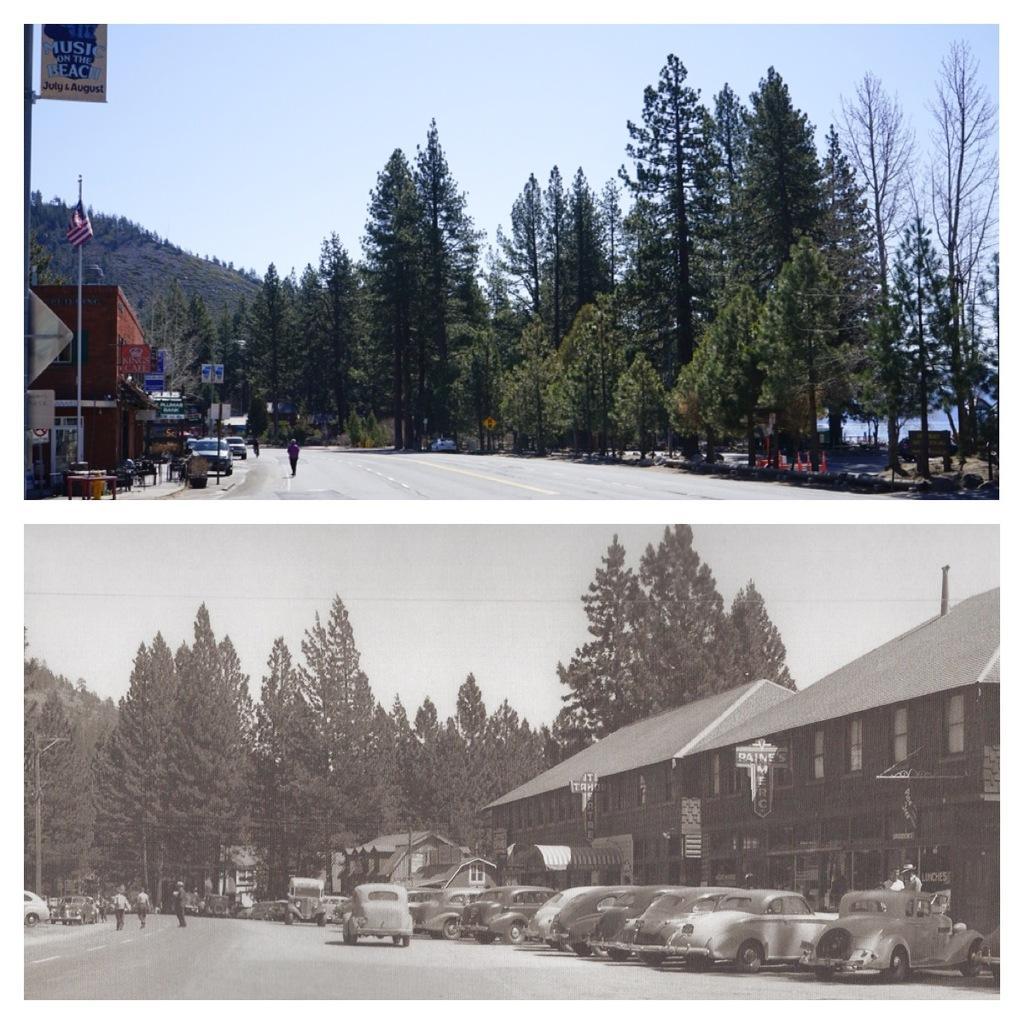Could you give a brief overview of what you see in this image? I can see this is a collage picture of two images. One image is normal and another one is in black and white. There are trees, few people, buildings, vehicles, name boards, there is a hill, there is a flag with pole and in the background there is sky in two images. 